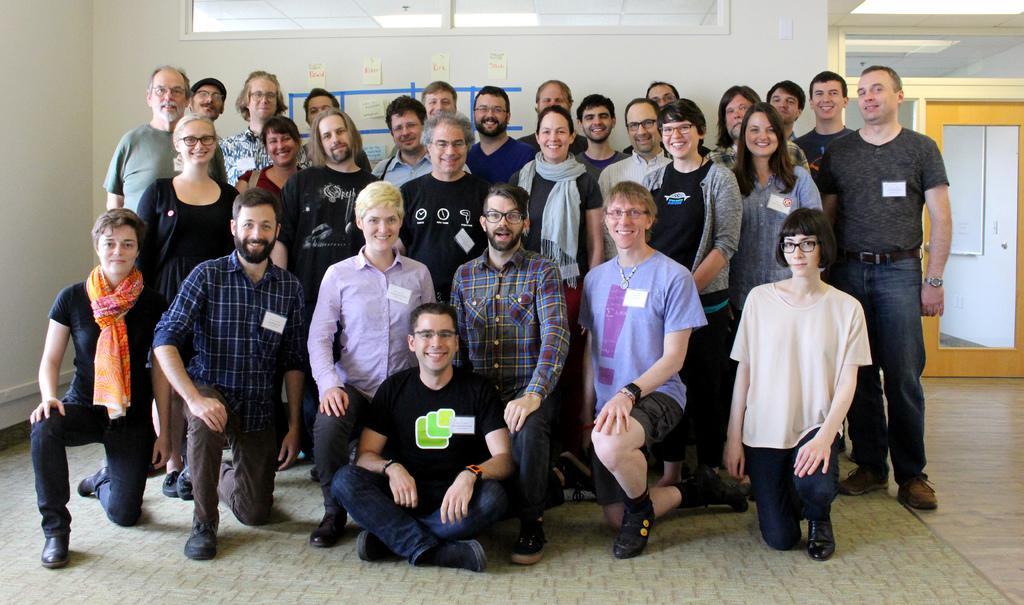How would you summarize this image in a sentence or two? In this picture we can see a group of people on the floor. Behind the people, there are pipes attached to the wall. At the top of the image, it looks like a window. On the right side of the image, there is a door and a white board. In the top right corner of the image, it looks like a ceiling light. 